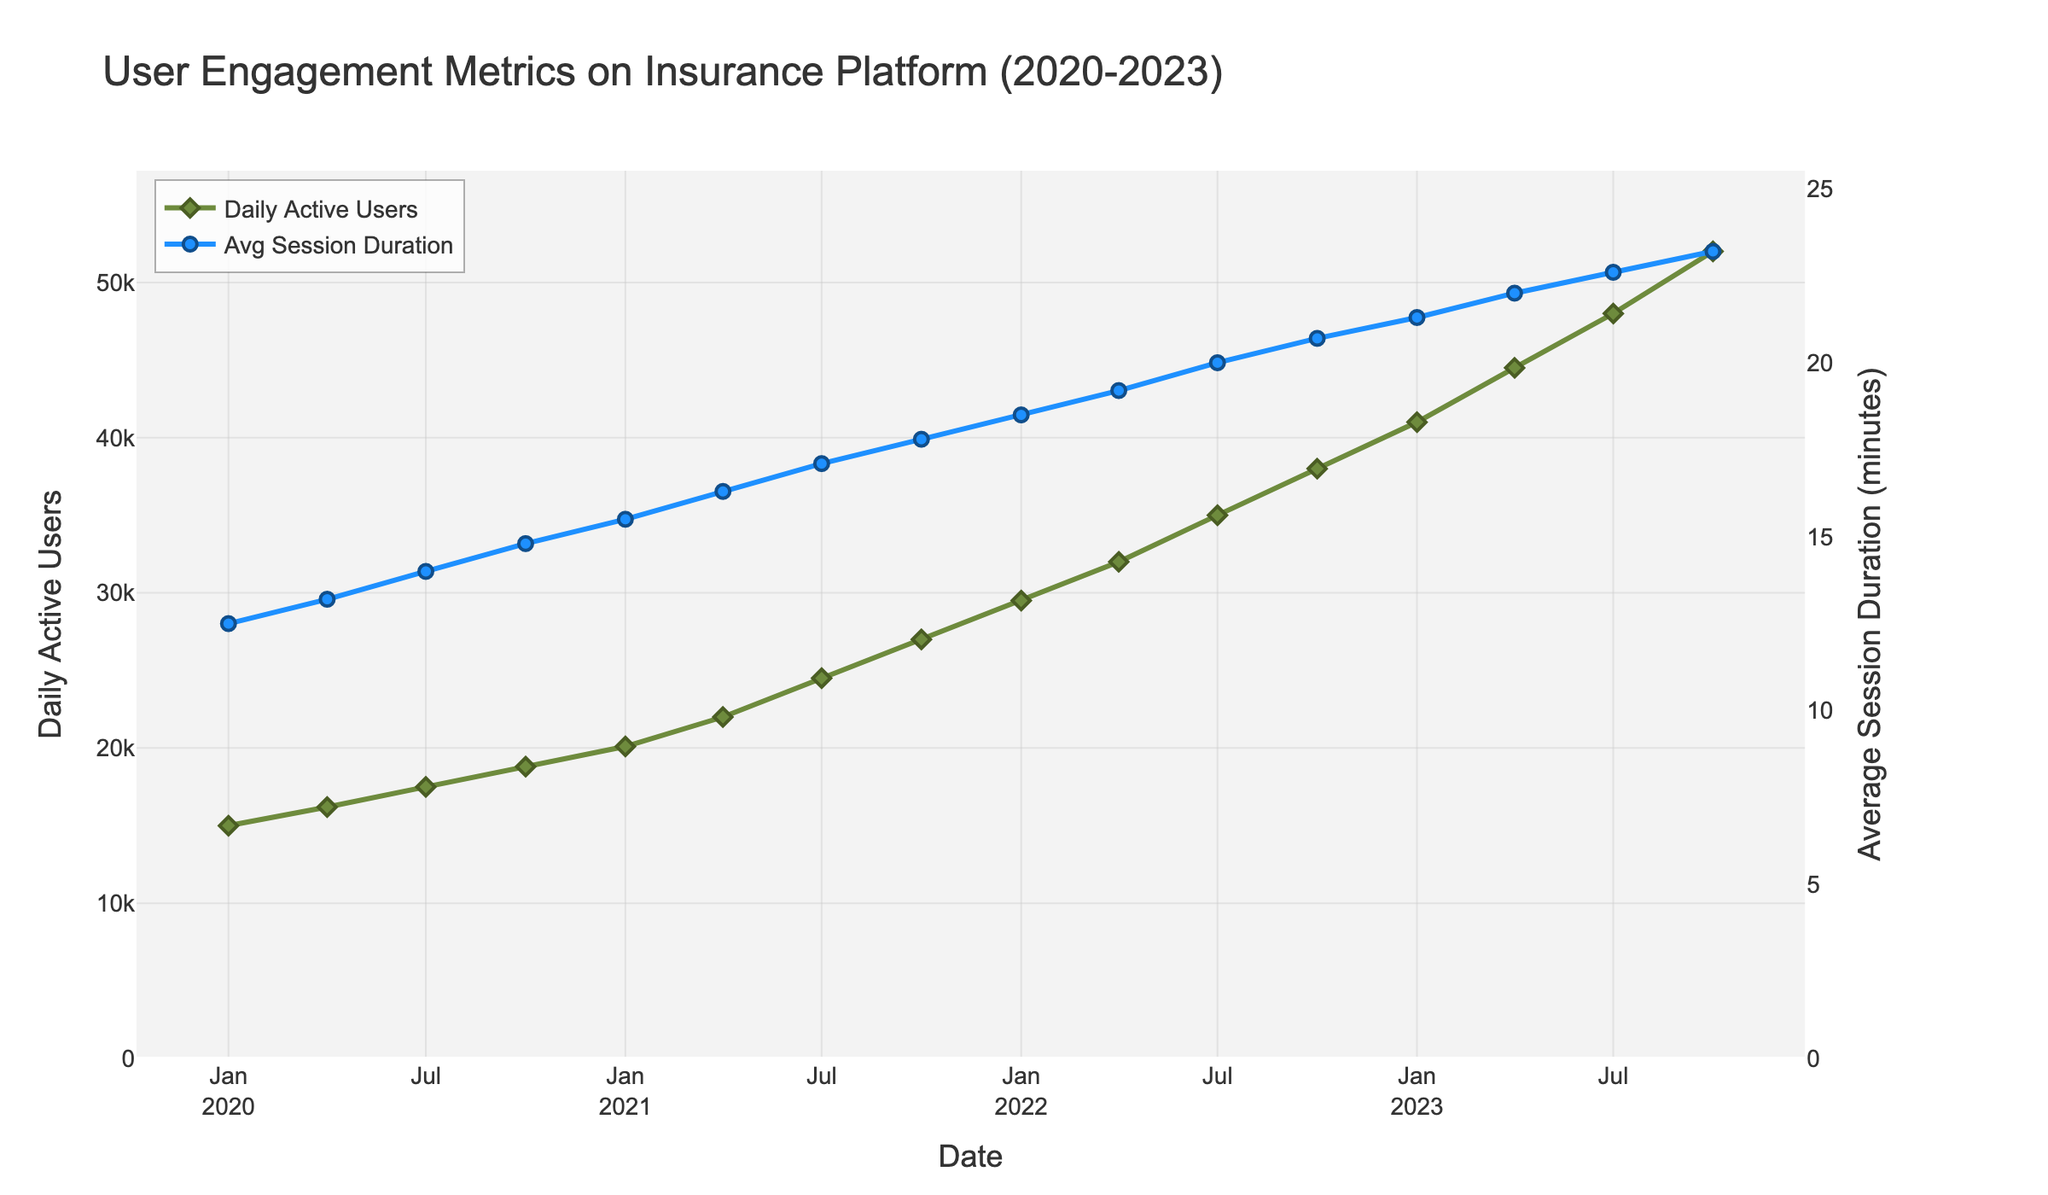What trend do you observe in the Daily Active Users over the last three years? The Daily Active Users metric continually increases throughout the entire three-year period shown in the chart, indicating a consistent growth in user engagement on the insurance platform.
Answer: Consistent increase Which quarter had the greatest increase in Daily Active Users? The greatest increase in Daily Active Users occurred between the quarters of April 2023 and July 2023. From the chart, Daily Active Users increased from 44,500 to 48,000, an increase of 3,500 users, making it the largest quarter-over-quarter increase shown.
Answer: April 2023 to July 2023 How did the Average Session Duration change from January 2022 to January 2023? The Average Session Duration in January 2022 was 18.5 minutes, and it increased to 21.3 minutes in January 2023. This shows an increase of 2.8 minutes over the one-year period.
Answer: Increased by 2.8 minutes Compare the Daily Active Users and Average Session Duration on October 2020 and October 2023. On October 2020, the Daily Active Users were 18,800 and the Average Session Duration was 14.8 minutes. By October 2023, the Daily Active Users increased to 52,000 and the Average Session Duration to 23.2 minutes. This shows a substantial increase in both metrics over the three years.
Answer: Both metrics increased significantly Which year had the highest average Daily Active Users? To find the year with the highest average Daily Active Users, we need to calculate the average for each year. For 2023, the average is (41,000 + 44,500 + 48,000 + 52,000) / 4 = 46,375, which is higher than the averages for 2020 (16875), 2021 (23,900), and 2022 (33,125). Thus, 2023 had the highest average.
Answer: 2023 During which period did the Average Session Duration exceed 20 minutes? From July 2022 to the end of the period (October 2023), the Average Session Duration consistently exceeded 20 minutes, as shown on the secondary y-axis.
Answer: From July 2022 onward Identify the month and year when Daily Active Users reached 30,000 for the first time. From the chart, Daily Active Users surpassed 30,000 for the first time in April 2022.
Answer: April 2022 How much did the Daily Active Users and Average Session Duration increase from the start to the end of the entire period? At the start (January 2020), there were 15,000 Daily Active Users and the Average Session Duration was 12.5 minutes. By the end (October 2023), these metrics had increased to 52,000 users and 23.2 minutes. The increments are 37,000 users and 10.7 minutes, respectively.
Answer: Increased by 37,000 users and 10.7 minutes 